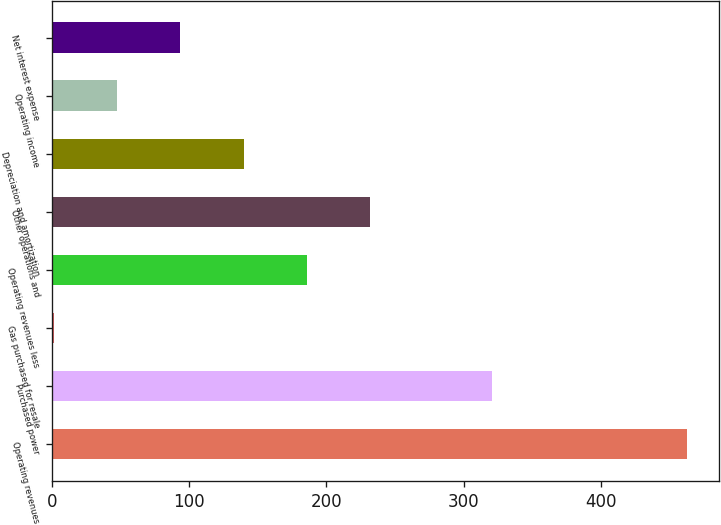<chart> <loc_0><loc_0><loc_500><loc_500><bar_chart><fcel>Operating revenues<fcel>Purchased power<fcel>Gas purchased for resale<fcel>Operating revenues less<fcel>Other operations and<fcel>Depreciation and amortization<fcel>Operating income<fcel>Net interest expense<nl><fcel>463<fcel>321<fcel>1<fcel>185.8<fcel>232<fcel>139.6<fcel>47.2<fcel>93.4<nl></chart> 